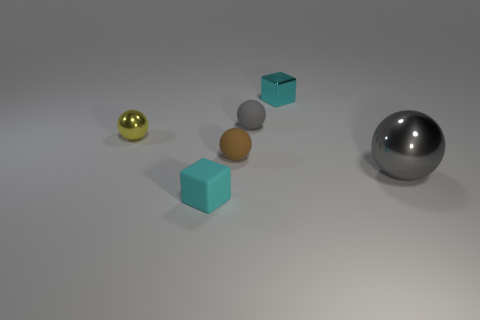Subtract all small brown rubber spheres. How many spheres are left? 3 Subtract all gray cylinders. How many gray spheres are left? 2 Add 2 red metallic balls. How many objects exist? 8 Subtract all gray spheres. How many spheres are left? 2 Subtract all cubes. How many objects are left? 4 Add 2 small blue shiny spheres. How many small blue shiny spheres exist? 2 Subtract 0 red balls. How many objects are left? 6 Subtract all green balls. Subtract all brown cylinders. How many balls are left? 4 Subtract all cyan matte balls. Subtract all tiny brown matte objects. How many objects are left? 5 Add 3 brown matte spheres. How many brown matte spheres are left? 4 